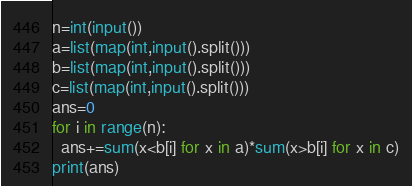<code> <loc_0><loc_0><loc_500><loc_500><_Python_>n=int(input())
a=list(map(int,input().split()))
b=list(map(int,input().split()))
c=list(map(int,input().split()))
ans=0
for i in range(n):
  ans+=sum(x<b[i] for x in a)*sum(x>b[i] for x in c)
print(ans)</code> 